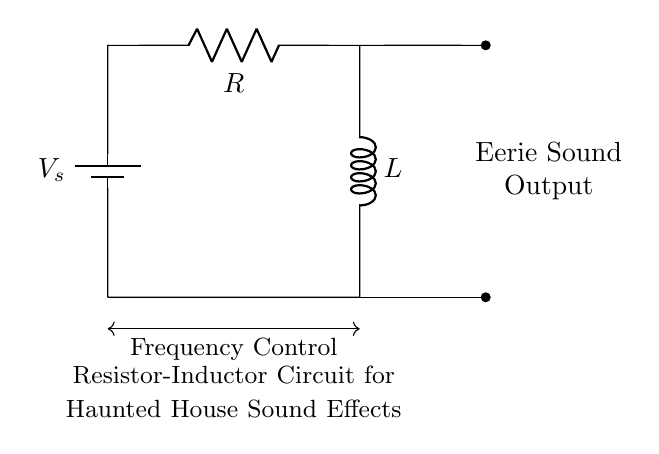What does the circuit consist of? The circuit includes a battery, a resistor, and an inductor, which are connected in series to form a closed loop.
Answer: battery, resistor, inductor What is the purpose of the resistor in this circuit? The resistor limits the current flow in the circuit, which affects the overall impedance and can influence the sound output characteristics.
Answer: current limiting What type of circuit is this? This is an R-L circuit, as it consists of a resistor and an inductor. It is specifically designed for sound effects, indicating a focus on audio applications.
Answer: R-L circuit How is the Eerie Sound Output generated? The Eerie Sound Output is generated through the interaction of the resistor and inductor, where the inductor's properties create oscillations, and the resistor shapes the waveform.
Answer: oscillations What type of configuration is used in this circuit? The configuration is a series connection, where the components are arranged in a line, allowing the same current to pass through each component sequentially.
Answer: series connection How does changing the values of the resistor and inductor affect the frequency? Changing the values of the resistor and inductor will alter the time constant of the circuit, influencing the resonant frequency and thus changing the pitch and quality of the sound produced.
Answer: alters frequency What is indicated by the arrows, labeled “Frequency Control”? The arrows indicate that adjustment to the resistor or inductor will result in a change in frequency, showcasing that the circuit is tunable for varying sound effects.
Answer: tunable frequency 